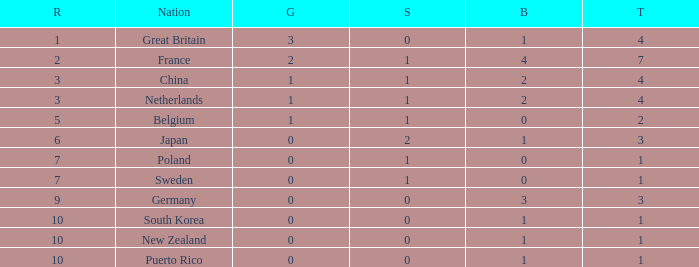What is the total where the gold is larger than 2? 1.0. 